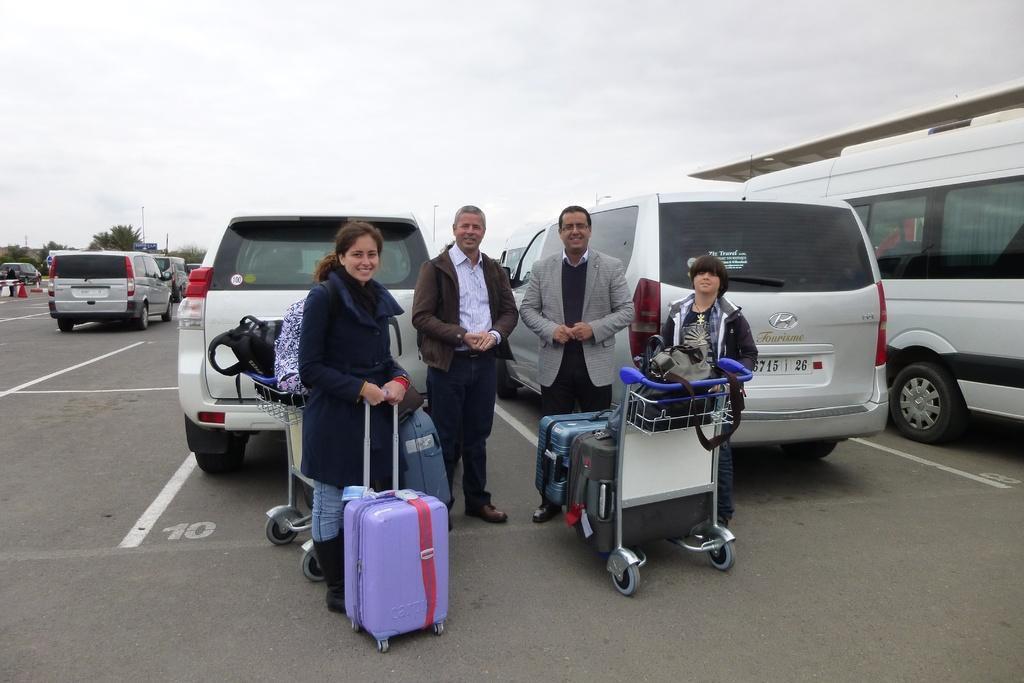Can you describe this image briefly? In this image we can see people are standing on the road. There are luggage bags, trolleys, vehicles, trees, and poles. In the background there is sky. 